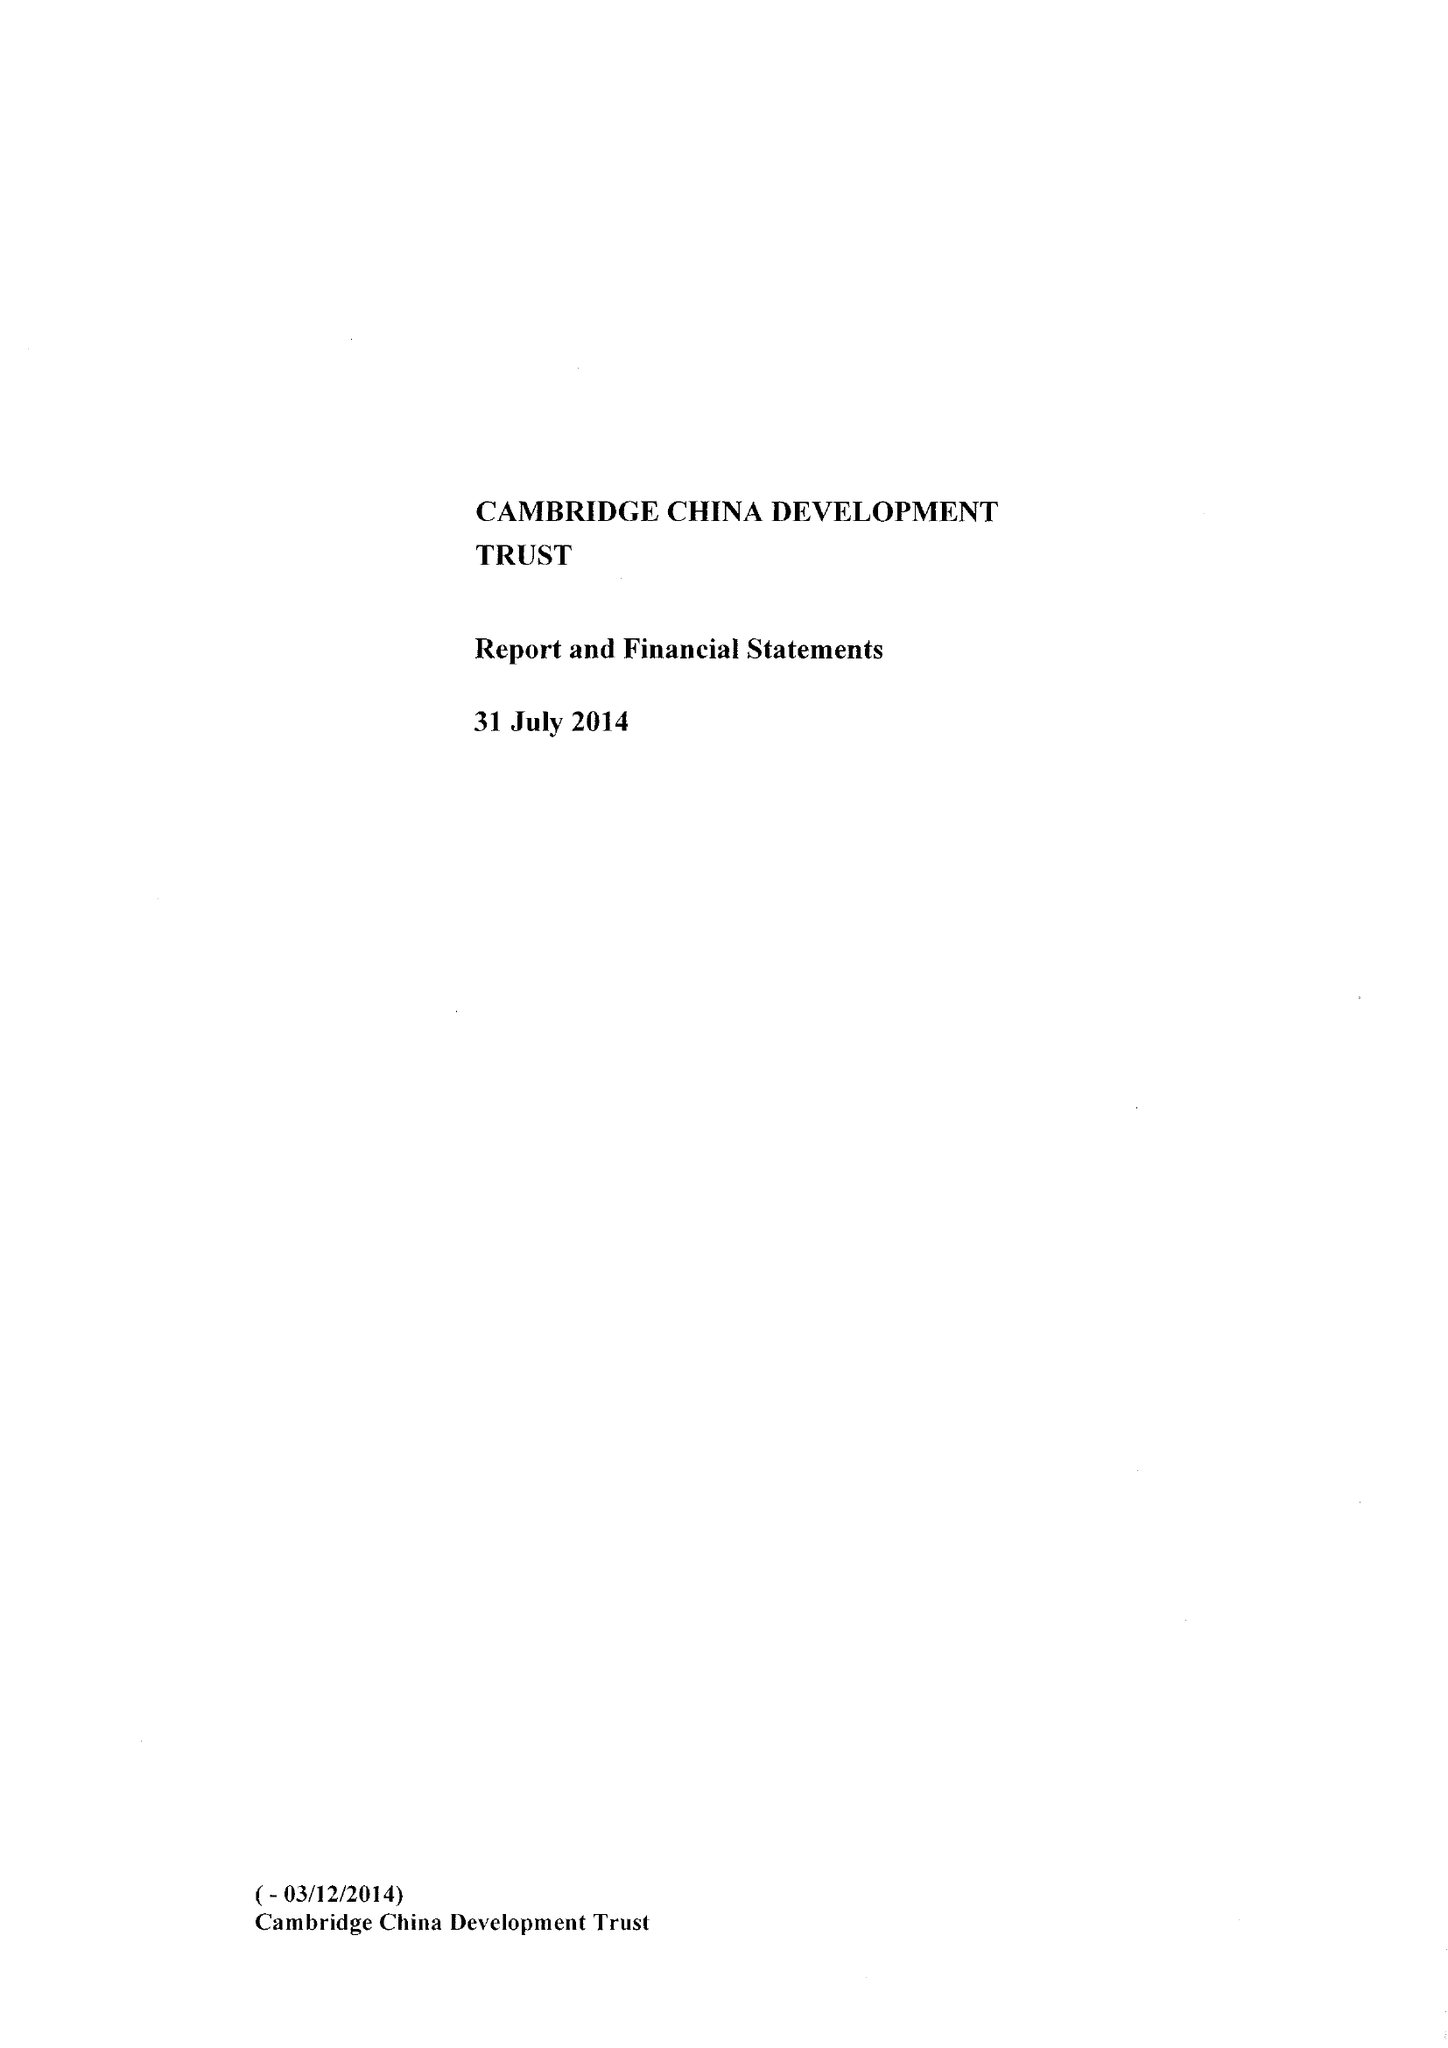What is the value for the spending_annually_in_british_pounds?
Answer the question using a single word or phrase. 266290.00 